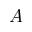Convert formula to latex. <formula><loc_0><loc_0><loc_500><loc_500>A</formula> 